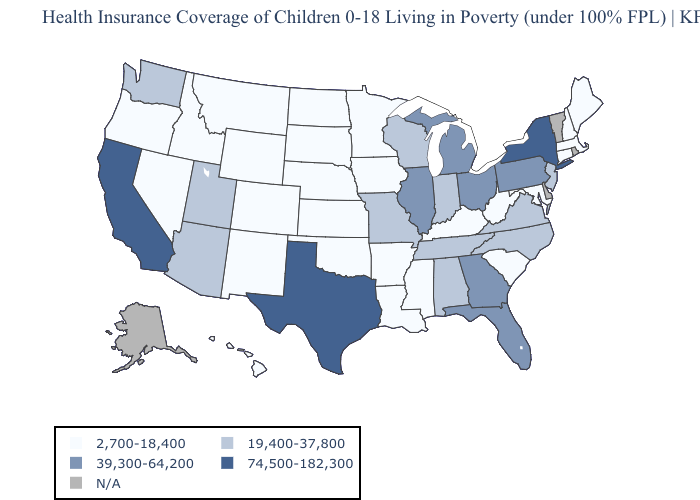Name the states that have a value in the range 74,500-182,300?
Concise answer only. California, New York, Texas. Is the legend a continuous bar?
Write a very short answer. No. Does Wyoming have the lowest value in the USA?
Give a very brief answer. Yes. Name the states that have a value in the range N/A?
Concise answer only. Alaska, Delaware, Rhode Island, Vermont. Among the states that border Georgia , does North Carolina have the highest value?
Give a very brief answer. No. Name the states that have a value in the range 2,700-18,400?
Write a very short answer. Arkansas, Colorado, Connecticut, Hawaii, Idaho, Iowa, Kansas, Kentucky, Louisiana, Maine, Maryland, Massachusetts, Minnesota, Mississippi, Montana, Nebraska, Nevada, New Hampshire, New Mexico, North Dakota, Oklahoma, Oregon, South Carolina, South Dakota, West Virginia, Wyoming. Among the states that border Utah , does Arizona have the lowest value?
Keep it brief. No. Name the states that have a value in the range 2,700-18,400?
Short answer required. Arkansas, Colorado, Connecticut, Hawaii, Idaho, Iowa, Kansas, Kentucky, Louisiana, Maine, Maryland, Massachusetts, Minnesota, Mississippi, Montana, Nebraska, Nevada, New Hampshire, New Mexico, North Dakota, Oklahoma, Oregon, South Carolina, South Dakota, West Virginia, Wyoming. Which states hav the highest value in the MidWest?
Write a very short answer. Illinois, Michigan, Ohio. Among the states that border Oregon , which have the highest value?
Answer briefly. California. What is the value of Wyoming?
Be succinct. 2,700-18,400. Is the legend a continuous bar?
Write a very short answer. No. Name the states that have a value in the range N/A?
Quick response, please. Alaska, Delaware, Rhode Island, Vermont. 